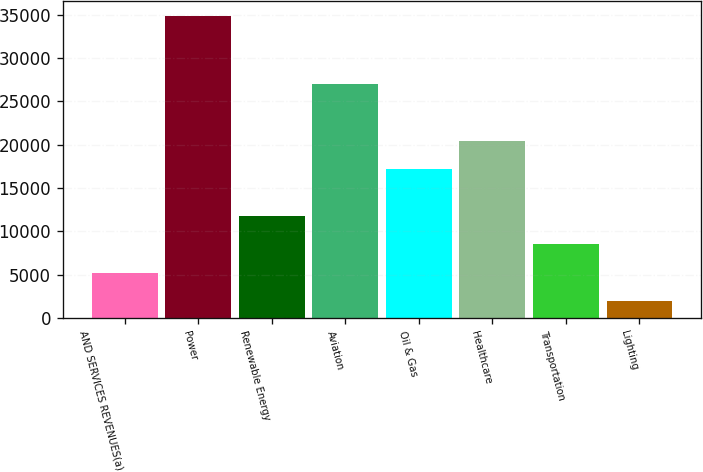Convert chart. <chart><loc_0><loc_0><loc_500><loc_500><bar_chart><fcel>AND SERVICES REVENUES(a)<fcel>Power<fcel>Renewable Energy<fcel>Aviation<fcel>Oil & Gas<fcel>Healthcare<fcel>Transportation<fcel>Lighting<nl><fcel>5234.7<fcel>34878<fcel>11822.1<fcel>27013<fcel>17180<fcel>20473.7<fcel>8528.4<fcel>1941<nl></chart> 